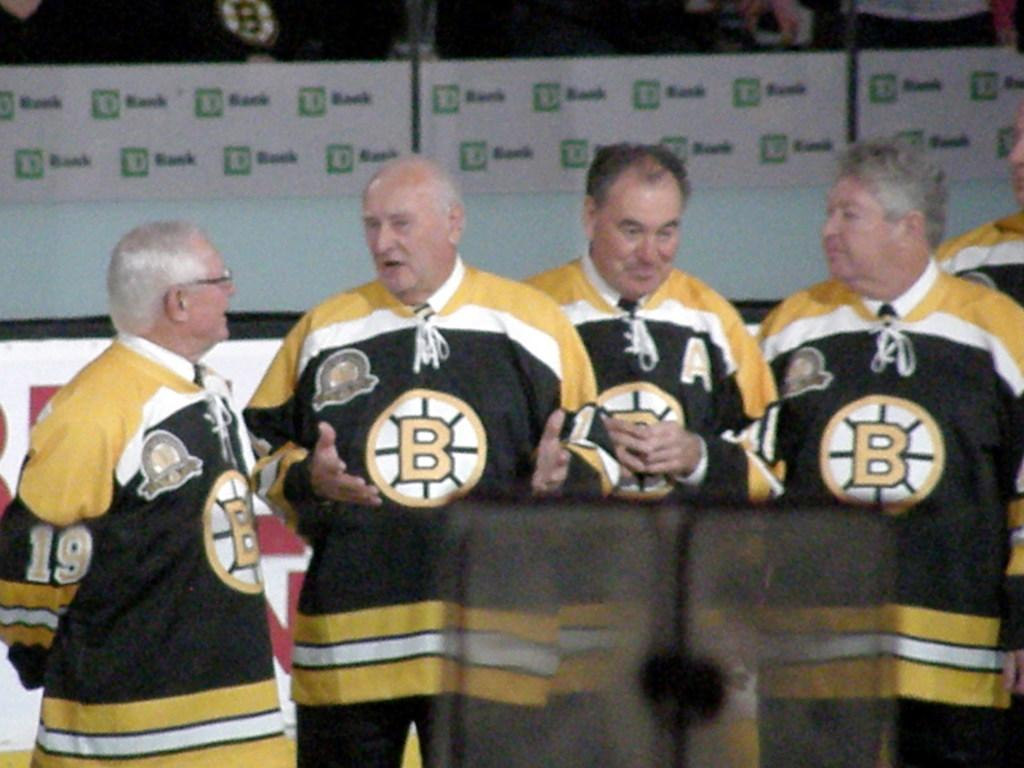<image>
Offer a succinct explanation of the picture presented. Four men standing together wearing jerseys that has the letter B on it. 